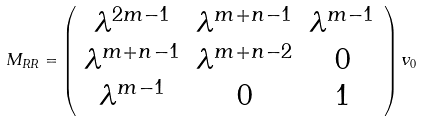Convert formula to latex. <formula><loc_0><loc_0><loc_500><loc_500>M _ { R R } = \left ( \begin{array} { c c c } \lambda ^ { 2 m - 1 } & \lambda ^ { m + n - 1 } & \lambda ^ { m - 1 } \\ \lambda ^ { m + n - 1 } & \lambda ^ { m + n - 2 } & 0 \\ \lambda ^ { m - 1 } & 0 & 1 \end{array} \right ) v _ { 0 }</formula> 